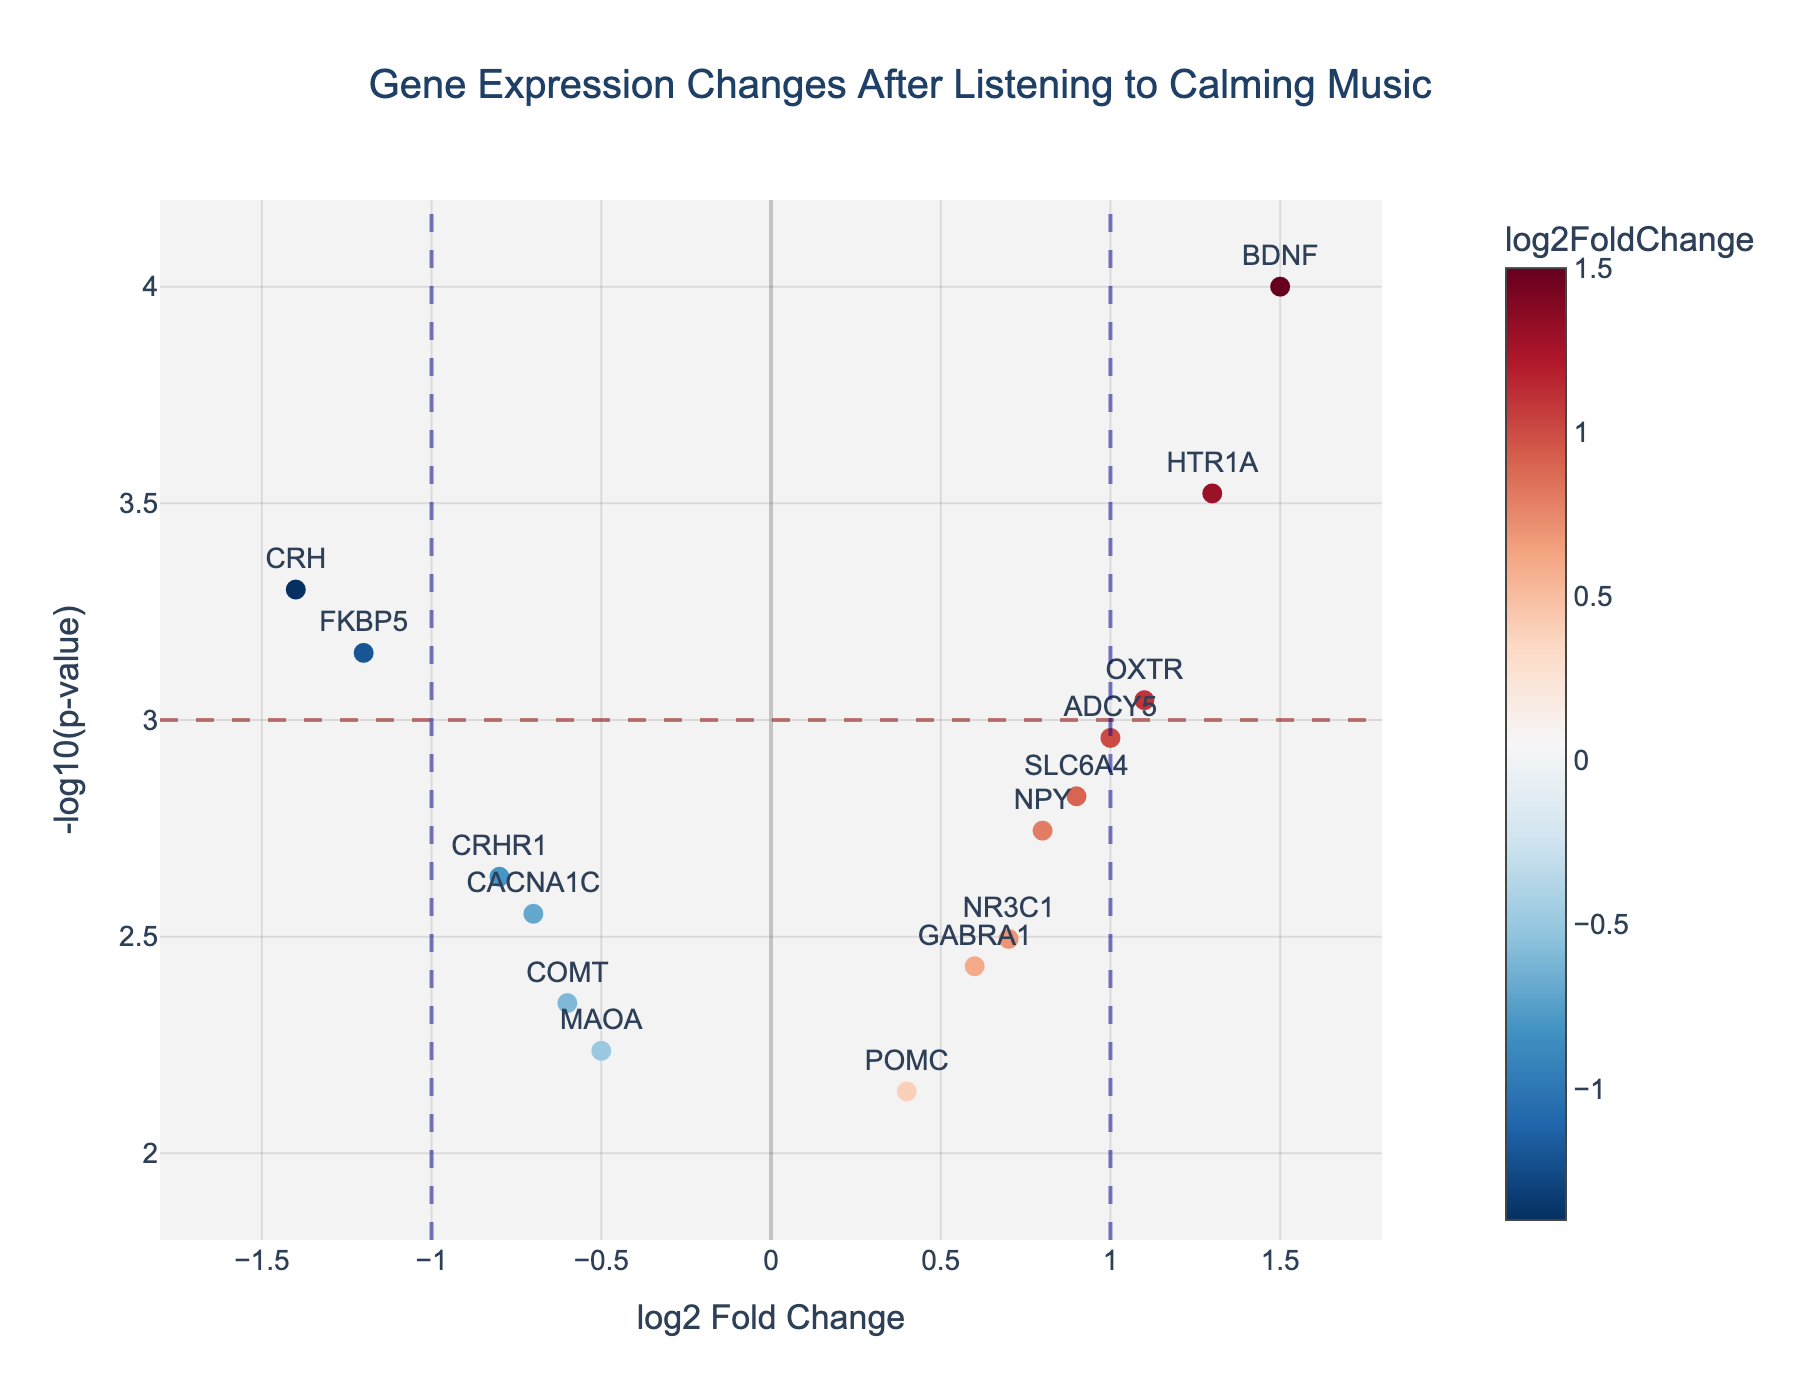How many genes show significant changes in expression after listening to calming music? Significant changes are typically highlighted by a threshold, here set at p-value = 0.001 (-log10(p-value) = 3). Count the dots above this horizontal line.
Answer: 9 What's the overall trend in gene expression changes in response to calming music? The overall trend can be observed from the distribution of data points on the x-axis. Both positive and negative log2 fold changes occur, with many significant changes highlighted above the threshold line.
Answer: Mixed Which gene exhibits the highest log2 fold change? Look for the gene with the highest absolute value along the x-axis of log2 fold change.
Answer: BDNF Which gene has the smallest p-value? The smallest p-value corresponds to the highest -log10(p-value). Check the dot positioned highest on the y-axis.
Answer: BDNF How does the expression of BDNF change in response to calming music? Locate BDNF on the plot and check its position on the x-axis to understand if its expression increases or decreases (positive or negative log2 fold change).
Answer: Increases Which genes have a greater than 1 log2 fold change? Identify points on the plot with log2 fold change greater than 1 (right of the vertical line at x=1).
Answer: BDNF, HTR1A, OXTR Are there any genes with decreased expression (negative log2 fold change) that are also significant? Find genes on the left x-axis (negative log2 fold change) and above the y-axis threshold (p-value = 0.001, -log10(p-value) = 3).
Answer: CRH, FKBP5, CRHR1 Which gene has the lowest expression change while still being statistically significant? Look for the gene just above the significance threshold line on the y-axis with the lowest absolute value on the x-axis (close to zero).
Answer: CACNA1C How does the expression of CRH change, and how significant is it? Locate CRH on the plot and note its x-axis (log2 fold change) for direction and magnitude, and y-axis (-log10(p-value)) for significance.
Answer: Decreases, highly significant 